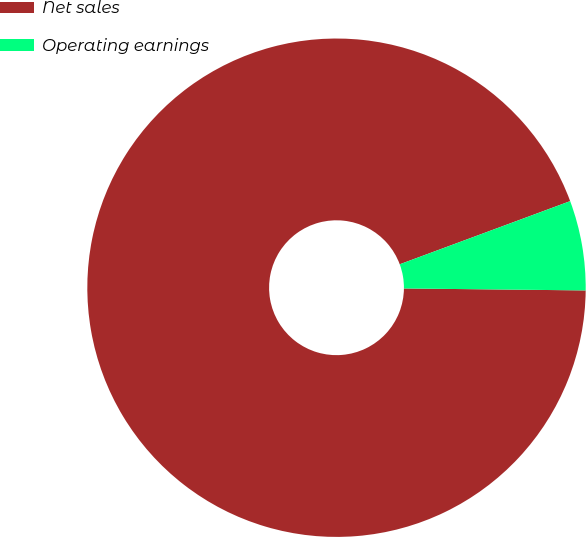Convert chart to OTSL. <chart><loc_0><loc_0><loc_500><loc_500><pie_chart><fcel>Net sales<fcel>Operating earnings<nl><fcel>94.18%<fcel>5.82%<nl></chart> 